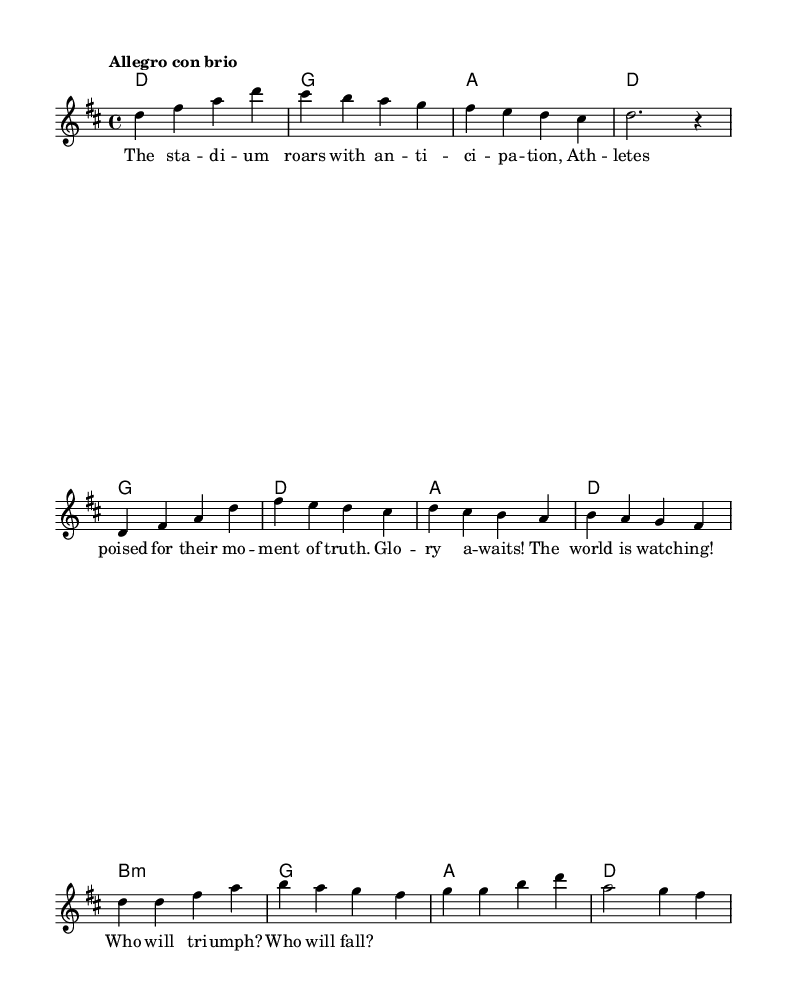What is the key signature of this music? The key signature is indicated at the beginning of the score and shows two sharps, which corresponds to D major.
Answer: D major What is the time signature of this music? The time signature appears at the beginning of the score as 4 over 4, representing four beats per measure.
Answer: 4/4 What is the tempo marking for this piece? The tempo marking states "Allegro con brio," which indicates a lively and brisk pace.
Answer: Allegro con brio How many bars are in the introduction section? The introduction section has four measures, as observed in the initial part of the melody.
Answer: 4 Which word denotes the climax in the chorus? The word "Glo -- ry" serves as the focal point of excitement and anticipation in the chorus lyrics.
Answer: Glo -- ry What is the emotional context implied by the lyrics "Who will triumph? Who will fall?" These lyrics evoke tension and suspense, as they directly reference the high-stakes nature of competition.
Answer: Tension and suspense 